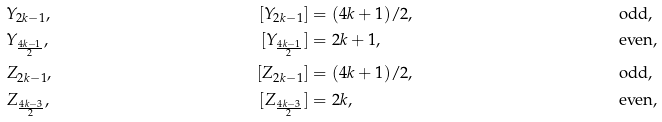<formula> <loc_0><loc_0><loc_500><loc_500>& Y _ { 2 k - 1 } , & [ Y _ { 2 k - 1 } ] & = ( 4 k + 1 ) / 2 , & & \text {odd} , \\ & Y _ { \frac { 4 k - 1 } { 2 } } , & [ Y _ { \frac { 4 k - 1 } { 2 } } ] & = 2 k + 1 , & & \text {even} , \\ & Z _ { 2 k - 1 } , & [ Z _ { 2 k - 1 } ] & = ( 4 k + 1 ) / 2 , & & \text {odd} , \\ & Z _ { \frac { 4 k - 3 } { 2 } } , & [ Z _ { \frac { 4 k - 3 } { 2 } } ] & = 2 k , & & \text {even} ,</formula> 